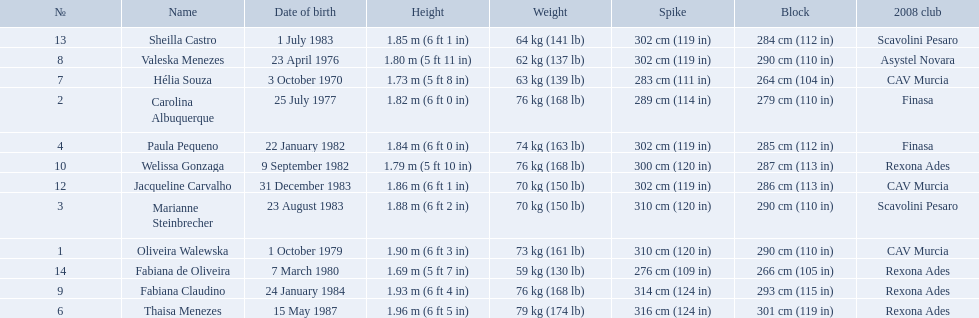What are all of the names? Oliveira Walewska, Carolina Albuquerque, Marianne Steinbrecher, Paula Pequeno, Thaisa Menezes, Hélia Souza, Valeska Menezes, Fabiana Claudino, Welissa Gonzaga, Jacqueline Carvalho, Sheilla Castro, Fabiana de Oliveira. What are their weights? 73 kg (161 lb), 76 kg (168 lb), 70 kg (150 lb), 74 kg (163 lb), 79 kg (174 lb), 63 kg (139 lb), 62 kg (137 lb), 76 kg (168 lb), 76 kg (168 lb), 70 kg (150 lb), 64 kg (141 lb), 59 kg (130 lb). How much did helia souza, fabiana de oliveira, and sheilla castro weigh? Hélia Souza, Sheilla Castro, Fabiana de Oliveira. And who weighed more? Sheilla Castro. What are the heights of the players? 1.90 m (6 ft 3 in), 1.82 m (6 ft 0 in), 1.88 m (6 ft 2 in), 1.84 m (6 ft 0 in), 1.96 m (6 ft 5 in), 1.73 m (5 ft 8 in), 1.80 m (5 ft 11 in), 1.93 m (6 ft 4 in), 1.79 m (5 ft 10 in), 1.86 m (6 ft 1 in), 1.85 m (6 ft 1 in), 1.69 m (5 ft 7 in). Which of these heights is the shortest? 1.69 m (5 ft 7 in). Which player is 5'7 tall? Fabiana de Oliveira. 